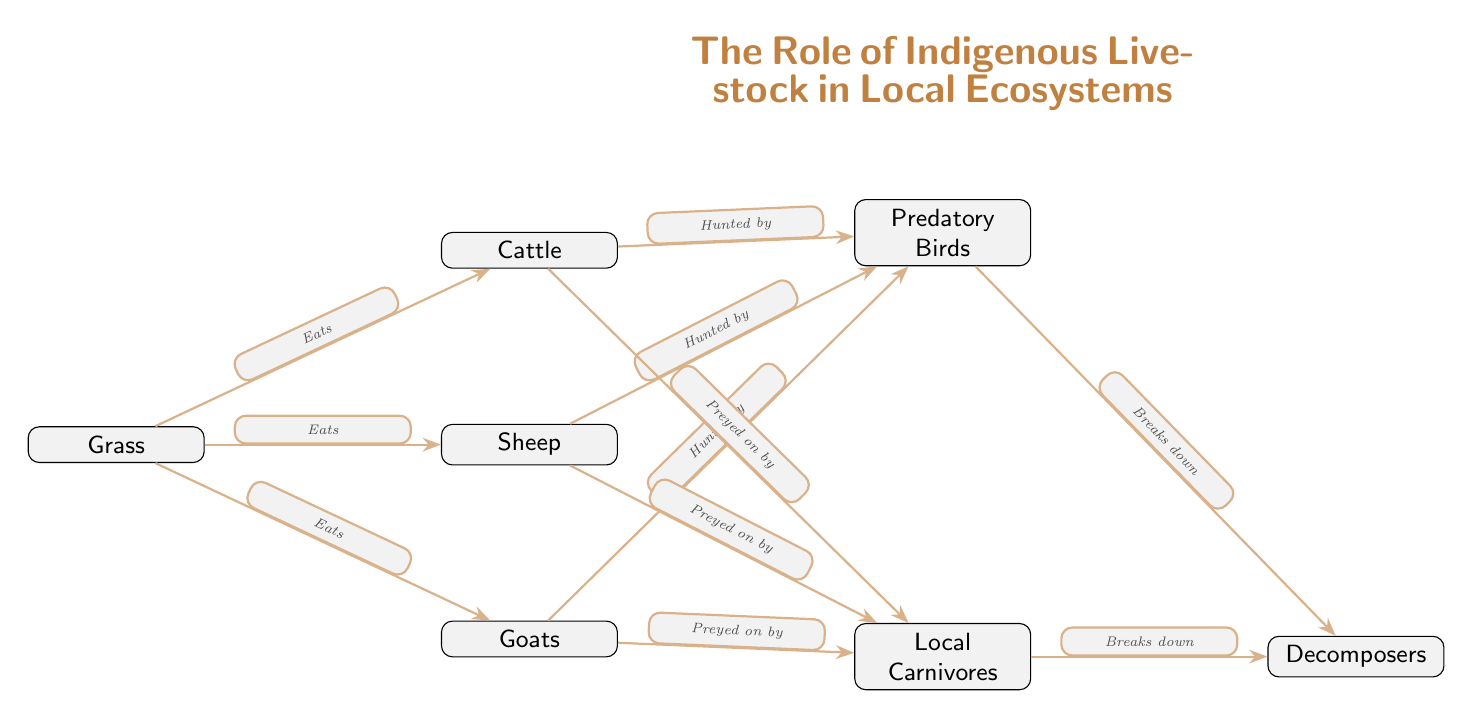What is the primary producer in this food chain? The primary producer, which is the foundation of the food chain, is represented by the first node, which is Grass.
Answer: Grass How many livestock types are directly consuming grass? The diagram shows three livestock types that eat grass: Cattle, Sheep, and Goats. Counting these gives us three types of livestock.
Answer: Three Which animals are predators in this ecosystem? The predators in this food chain are represented by the node "Predatory Birds". These birds are indicated as hunting the livestock types listed.
Answer: Predatory Birds How many species prey on the livestock? The diagram mentions two types of predatory animals that prey on the livestock: Birds and Local Carnivores. By examining the nodes connected to the livestock, we can confirm that there are two distinct types of predators.
Answer: Two What happens to the remains of the cattle after being hunted? The edge labeled "Breaks down" indicates that after being hunted, Cattle along with the other livestock are broken down by Decomposers, which means their remains are processed by these organisms.
Answer: Decomposers Which element consumes the cattle? The diagram shows an arrow from Cattle labeled "Hunted by", which points to Predatory Birds, indicating that the Predatory Birds consume the Cattle.
Answer: Predatory Birds How many total nodes are present in the diagram? The diagram consists of a total of eight nodes: Grass, Cattle, Sheep, Goats, Predatory Birds, Local Carnivores, and Decomposers (the title node is not counted). Counting these gives us seven nodes in total.
Answer: Seven Which group of animals serves as the decomposers in this ecosystem? The decomposers are shown in a specific node labeled "Decomposers", indicating their role in breaking down organic matter.
Answer: Decomposers What type of relationship exists between sheep and carnivores? The relationship is indicated by the edge labeled "Preyed on by", showing that Sheep are preyed upon by Local Carnivores in the ecosystem.
Answer: Preyed on by 